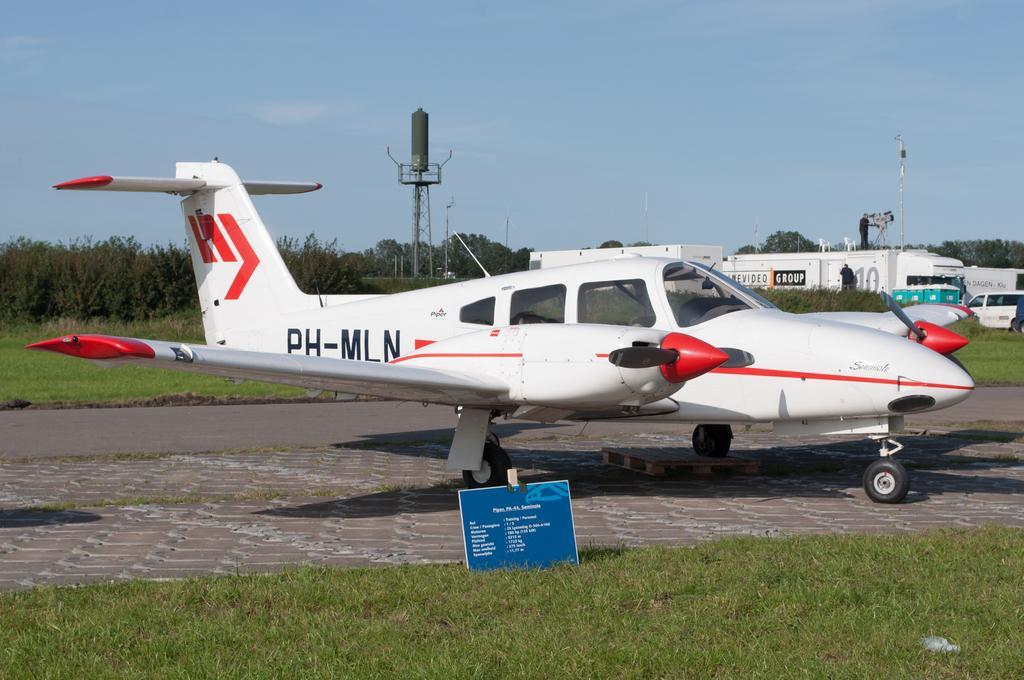Could you give a brief overview of what you see in this image? There is a white aeroplane. There is grass, trees and other vehicles. 